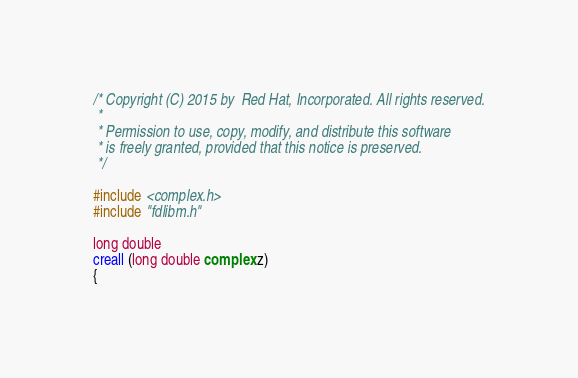<code> <loc_0><loc_0><loc_500><loc_500><_C_>/* Copyright (C) 2015 by  Red Hat, Incorporated. All rights reserved.
 *
 * Permission to use, copy, modify, and distribute this software
 * is freely granted, provided that this notice is preserved.
 */

#include <complex.h>
#include "fdlibm.h"

long double
creall (long double complex z)
{</code> 